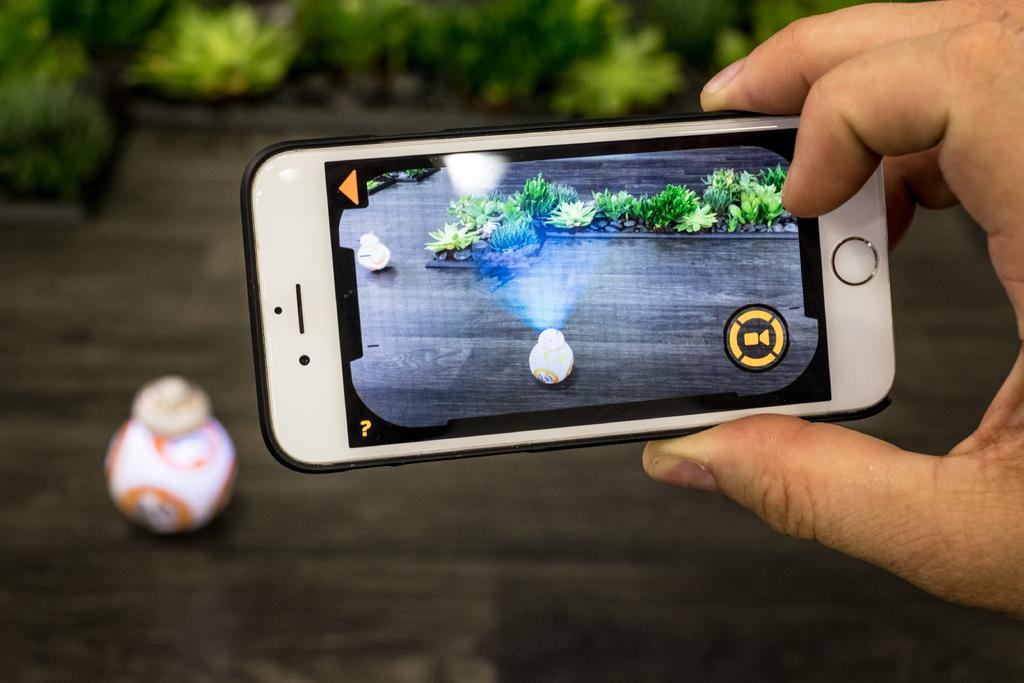What is being held by the person's hand in the image? There is a person's hand with a mobile in the image. What is displayed on the mobile screen? The mobile screen displays a pot. What type of vegetation is near the person's hand? There are plants near the person's hand. How would you describe the background of the image? The background of the image is blurry. Can you identify any other objects related to the pot in the image? Yes, there is a pot visible in the background. What type of record is being played by the person's tongue in the image? There is no record or tongue present in the image. Can you describe the branch that the person is holding in the image? There is no branch being held by the person in the image. 